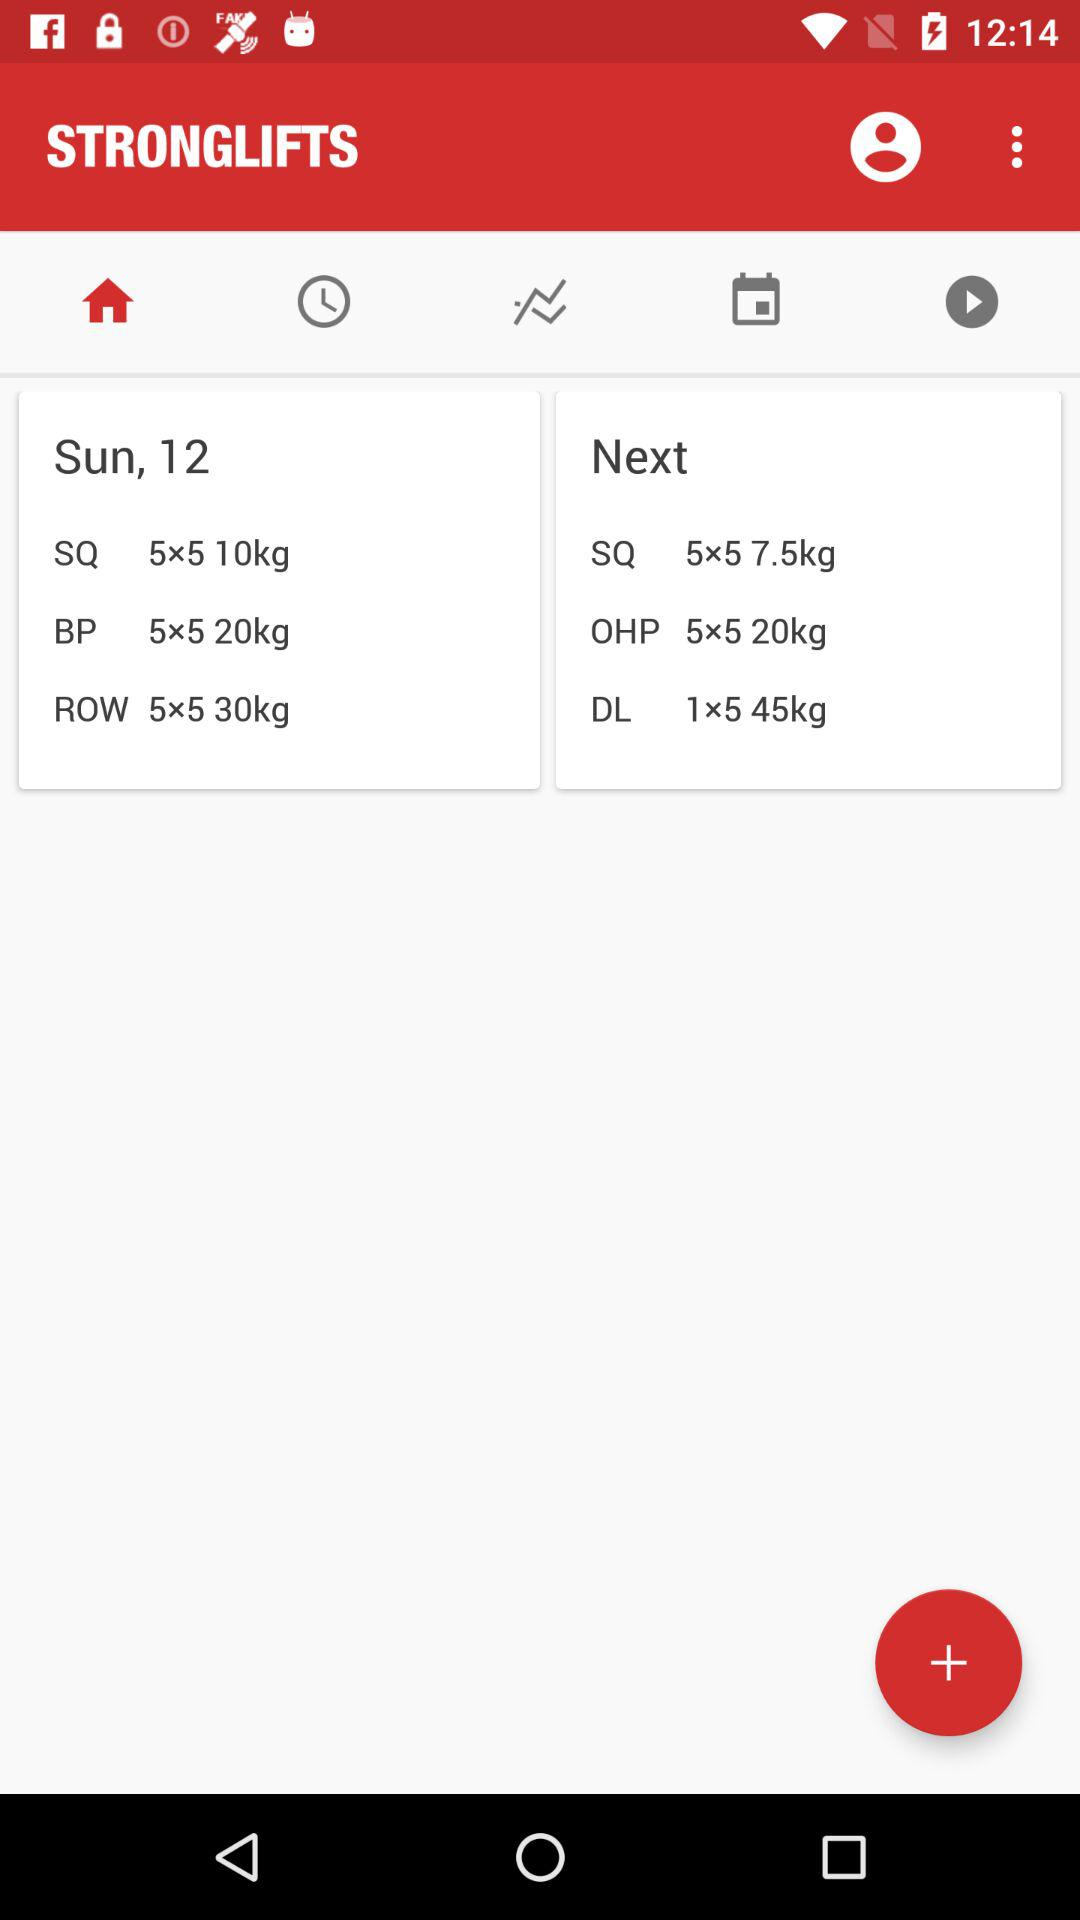What is the date? The date is Sunday, 12. 